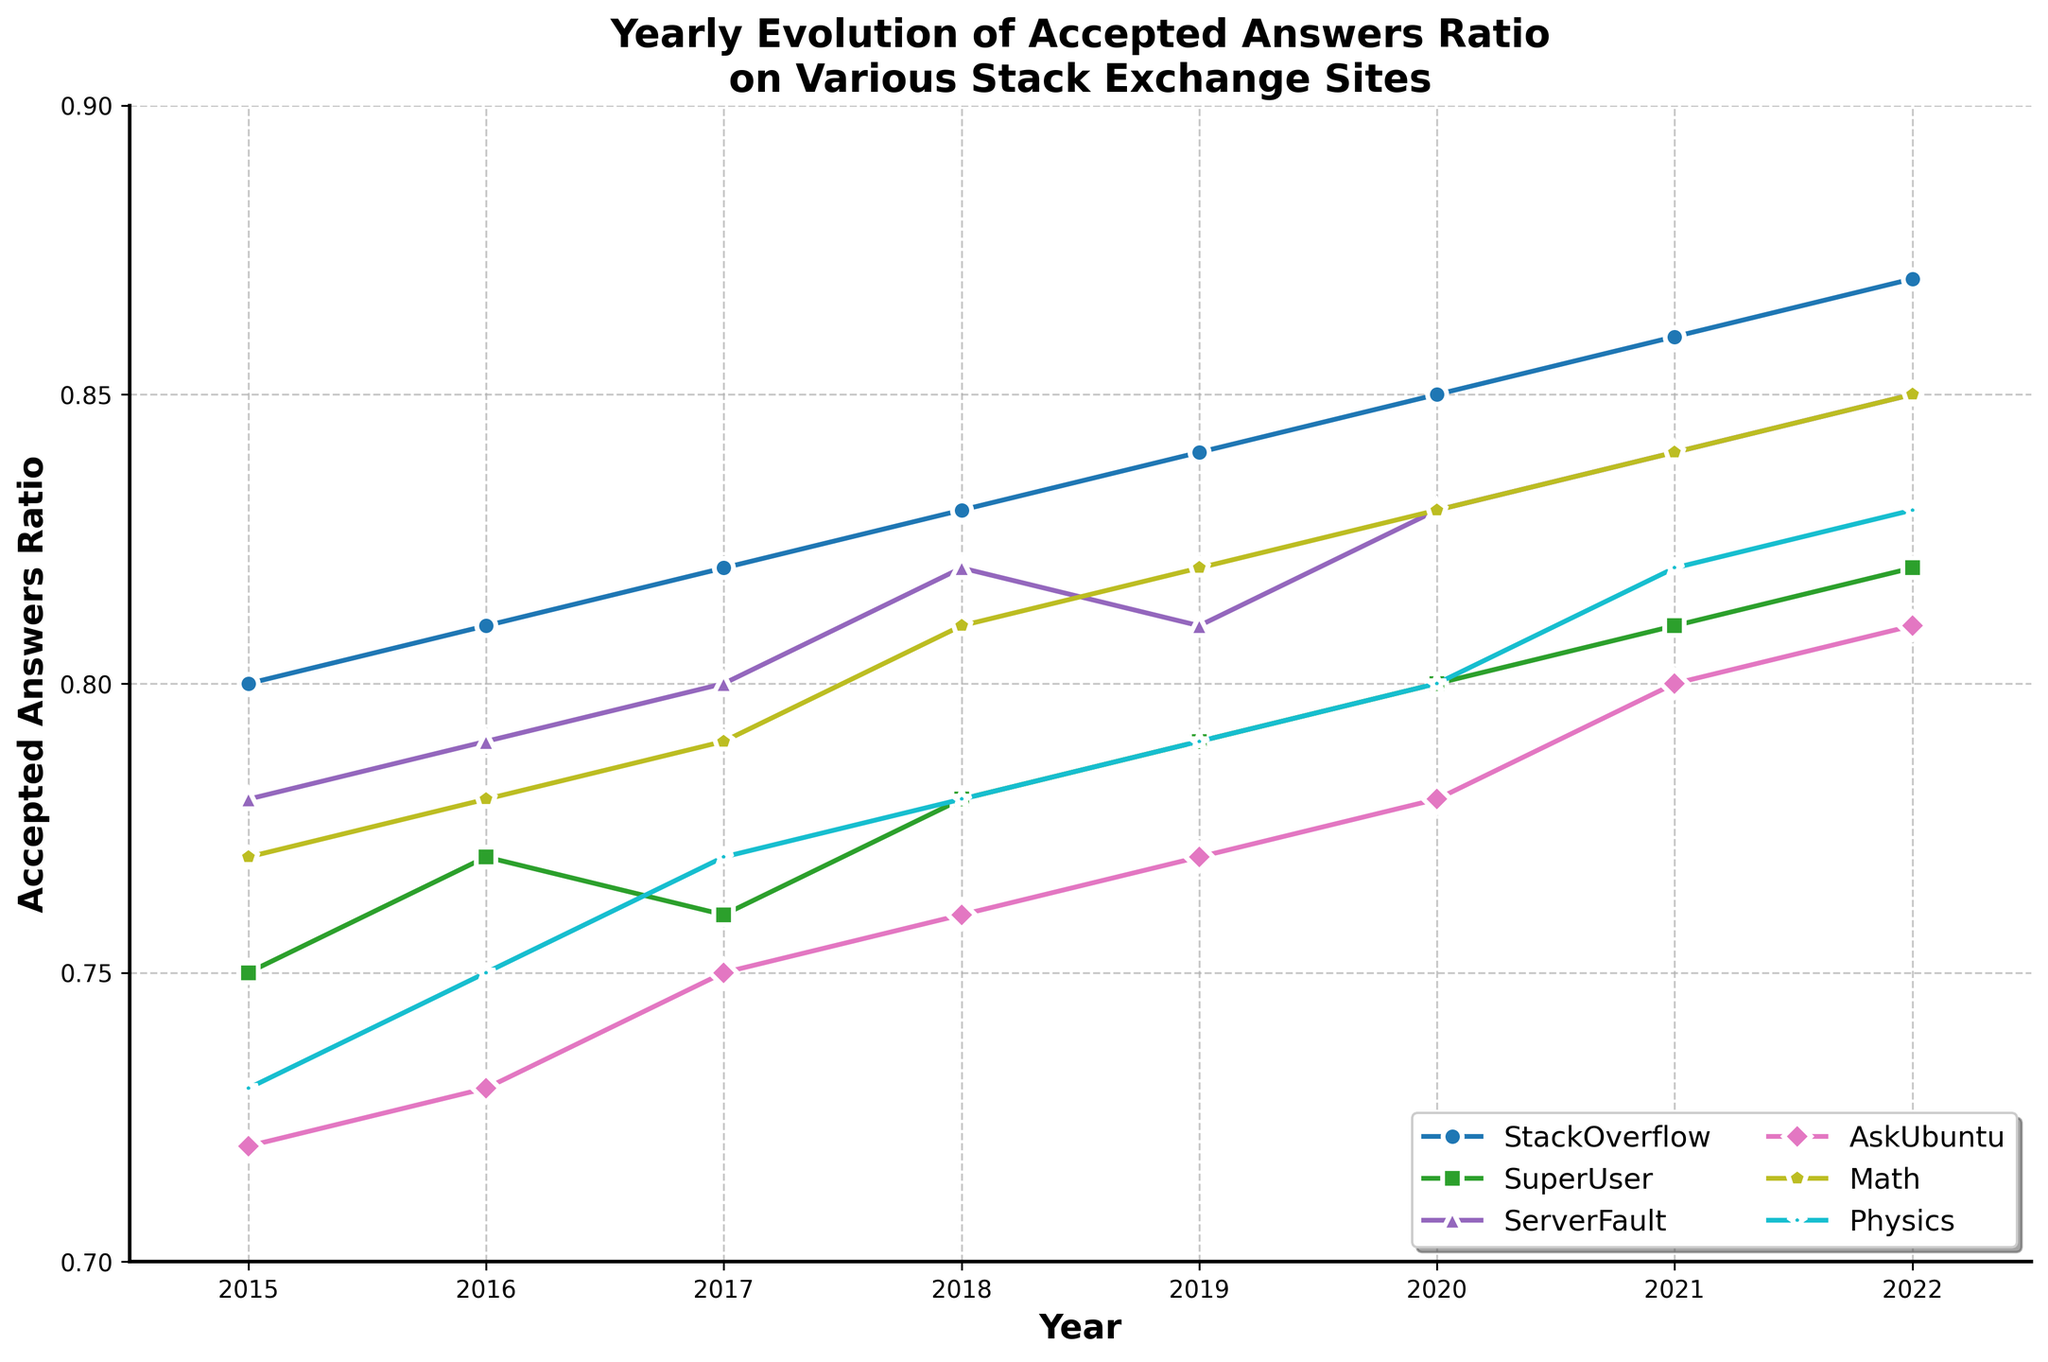What's the title of the figure? The title is located at the top of the figure and summarizes what the plot is about: "Yearly Evolution of Accepted Answers Ratio on Various Stack Exchange Sites".
Answer: Yearly Evolution of Accepted Answers Ratio on Various Stack Exchange Sites How many years are displayed in this time series plot? By looking at the x-axis, you can count the number of tick marks representing the years. Starting from 2015 to 2022, there are 8 years displayed.
Answer: 8 Which Stack Exchange site has the highest accepted answer ratio in 2022? By examining the plot and finding the values at the year 2022, StackOverflow has the highest ratio. This is indicated by the highest point among all lines for that year.
Answer: StackOverflow What is the range of accepted answer ratios displayed on the y-axis? The range is determined by the starting value and ending value of the y-axis, which go from 0.7 to 0.9.
Answer: 0.7 to 0.9 Which site shows the greatest overall increase in accepted answers ratio from 2015 to 2022? By evaluating the difference between the values in 2022 and 2015 for each site, StackOverflow shows the greatest increase (0.87 - 0.80 = 0.07).
Answer: StackOverflow By how much did the accepted answers ratio for AskUbuntu change from 2020 to 2022? The value for AskUbuntu in 2020 is 0.78, and in 2022 it is 0.81. The difference is calculated as 0.81 - 0.78 = 0.03.
Answer: 0.03 Between Math and Physics, which site had a higher accepted answer ratio in 2018? By inspecting the plot at the year 2018, it can be seen that the value for Math is slightly higher (0.81) than that of Physics (0.78).
Answer: Math What is the average accepted answer ratio for SuperUser across all years? Adding the ratios for SuperUser from 2015 to 2022 (0.75 + 0.77 + 0.76 + 0.78 + 0.79 + 0.80 + 0.81 + 0.82) and then dividing by the number of years (8) gives an average of (6.28 / 8) = 0.785.
Answer: 0.785 Does any site's accepted answer ratio decline in any year? By examining each site's line trajectory across the years, none of the sites show a decline in their accepted answer ratio; all consistently increase or stay the same.
Answer: No 